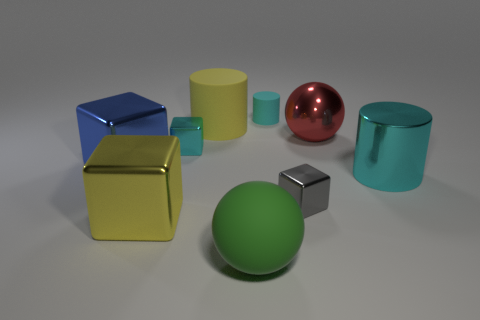Are there any red metal balls?
Keep it short and to the point. Yes. What is the tiny cube that is behind the cube right of the sphere that is in front of the cyan metal cube made of?
Provide a succinct answer. Metal. Is the number of large cyan cylinders that are in front of the large yellow matte cylinder less than the number of big yellow blocks?
Give a very brief answer. No. There is a cyan thing that is the same size as the red thing; what is its material?
Offer a terse response. Metal. There is a block that is both right of the big blue metal cube and behind the big metallic cylinder; what is its size?
Your answer should be compact. Small. There is a green thing that is the same shape as the large red metallic thing; what size is it?
Provide a succinct answer. Large. What number of things are large green metallic things or large spheres in front of the red metallic ball?
Provide a short and direct response. 1. What is the shape of the small matte thing?
Ensure brevity in your answer.  Cylinder. There is a small thing that is behind the large yellow cylinder to the left of the tiny gray shiny thing; what shape is it?
Provide a short and direct response. Cylinder. What is the material of the cube that is the same color as the small matte cylinder?
Your answer should be very brief. Metal. 